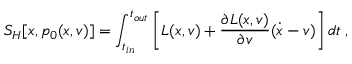<formula> <loc_0><loc_0><loc_500><loc_500>S _ { H } [ x , p _ { 0 } ( x , v ) ] = \int _ { t _ { i n } } ^ { t _ { o u t } } \left [ L ( x , v ) + \frac { \partial L ( x , v ) } { \partial v } ( \dot { x } - v ) \right ] d t \, ,</formula> 